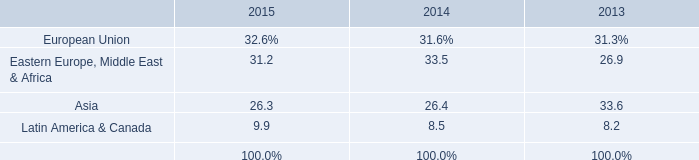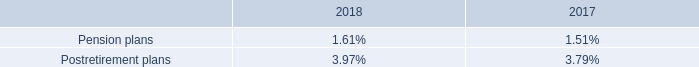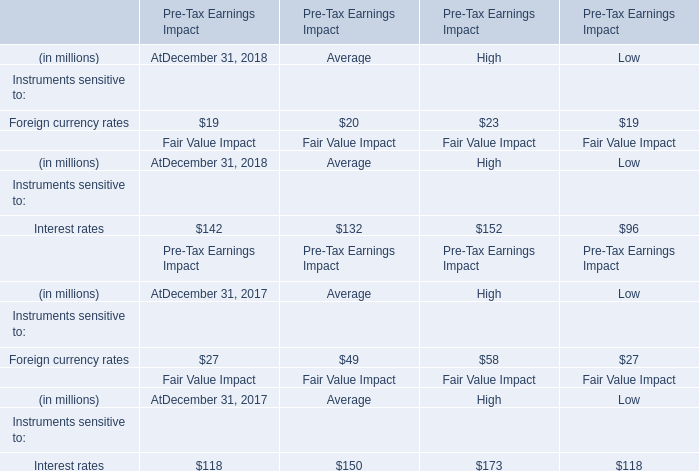What is the percentage of Instruments sensitive to:Foreign currency rates for Average in relation to the total for Average? 
Computations: (20 / (((20 + 132) + 49) + 150))
Answer: 0.05698. by what percentage will the 2019 pre-tax pension and postretirement expense be higher than that of 2018? 
Computations: ((205 - 160) / 160)
Answer: 0.28125. 